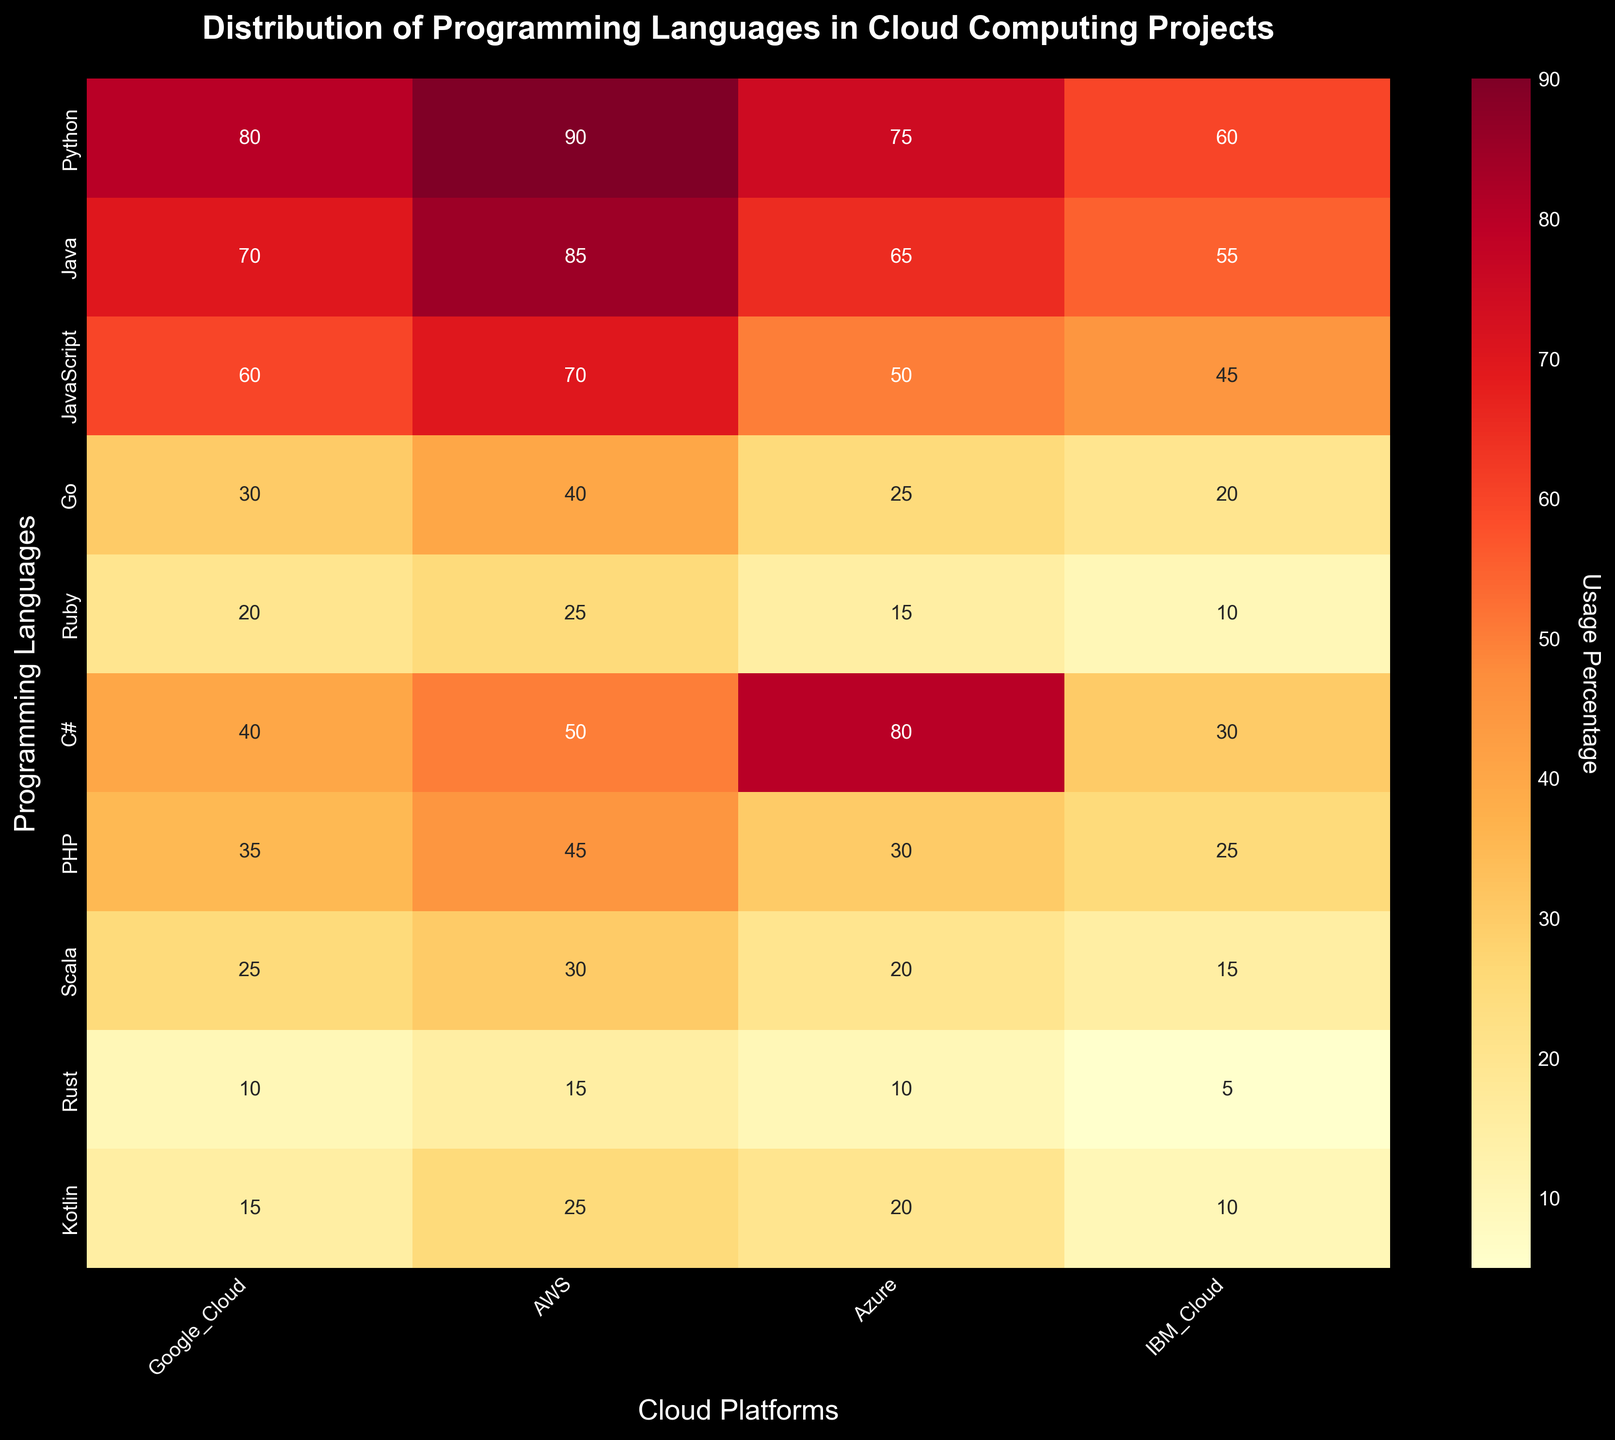What's the most used programming language for AWS? Look for the highest number in the AWS column. Python has 90, which is the highest value in that column.
Answer: Python What's the least used programming language across all cloud platforms? Identify the lowest value across the entire heatmap. Rust for IBM Cloud has the lowest value of 5.
Answer: Rust on IBM Cloud How many programming languages are used on Google Cloud? Count the number of unique programming languages listed on the y-axis. There are 10 languages listed.
Answer: 10 Which cloud platform has the highest usage percentage of C#? Compare the values of C# across all cloud platforms. Azure has the highest value for C# at 80.
Answer: Azure What is the title of the heatmap? Read the title at the top of the heatmap. It says "Distribution of Programming Languages in Cloud Computing Projects."
Answer: Distribution of Programming Languages in Cloud Computing Projects How does the usage of JavaScript on Azure compare to the usage of Go on AWS? Check the values for JavaScript on Azure and Go on AWS. JavaScript on Azure is 50, and Go on AWS is 40. JavaScript usage on Azure is higher.
Answer: JavaScript on Azure is higher Which programming language has the largest difference in usage between Google Cloud and IBM Cloud? Subtract the values of each programming language between Google Cloud and IBM Cloud, then find the maximum difference. Python has the largest difference. 80 (Google Cloud) - 60 (IBM Cloud) = 20, which is the largest.
Answer: Python What percentage does Ruby account for in AWS compared to PHP in Google Cloud? Identify the usage percentage for Ruby in AWS (25) and PHP in Google Cloud (35). Ruby accounts for a smaller percentage compared to PHP in Google Cloud.
Answer: Ruby is smaller What’s the average usage percentage of Python across all cloud platforms? Sum the Python values across Google Cloud, AWS, Azure, and IBM Cloud: 80 + 90 + 75 + 60 = 305. Then, divide by 4: 305/4 = 76.25.
Answer: 76.25 Is Scala more used on Azure or IBM Cloud? Look at Scala's values for Azure and IBM Cloud. Scala has 20 on Azure and 15 on IBM Cloud. Therefore, Scala is more used on Azure.
Answer: Azure 